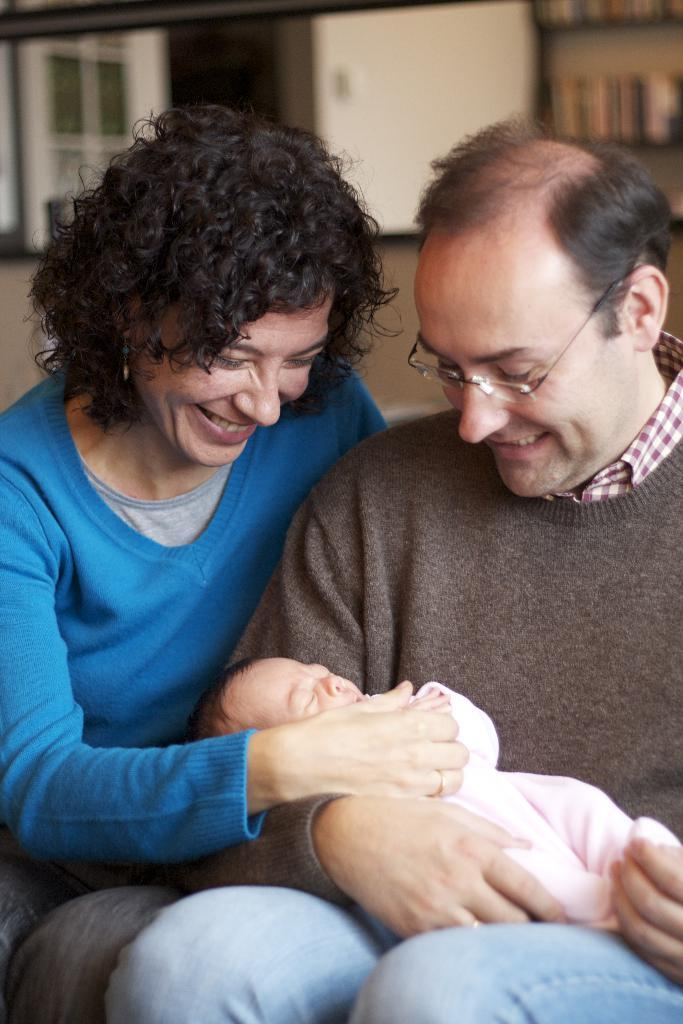Who are the people in the image? There is a woman and a man in the image. What is the man doing in the image? The man is holding a baby in the image. Can you describe the man's appearance? The man is wearing spectacles in the image. How are the people in the image feeling? Both the woman and the man are smiling in the image. What type of tent is visible in the image? There is no tent present in the image. 